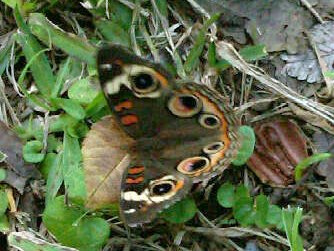<image>
Can you confirm if the butterfly is on the brown leaf? Yes. Looking at the image, I can see the butterfly is positioned on top of the brown leaf, with the brown leaf providing support. Is the grass to the right of the butterfly? Yes. From this viewpoint, the grass is positioned to the right side relative to the butterfly. 